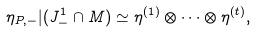Convert formula to latex. <formula><loc_0><loc_0><loc_500><loc_500>\eta _ { P , - } | ( J _ { - } ^ { 1 } \cap M ) \simeq \eta ^ { ( 1 ) } \otimes \cdots \otimes \eta ^ { ( t ) } ,</formula> 